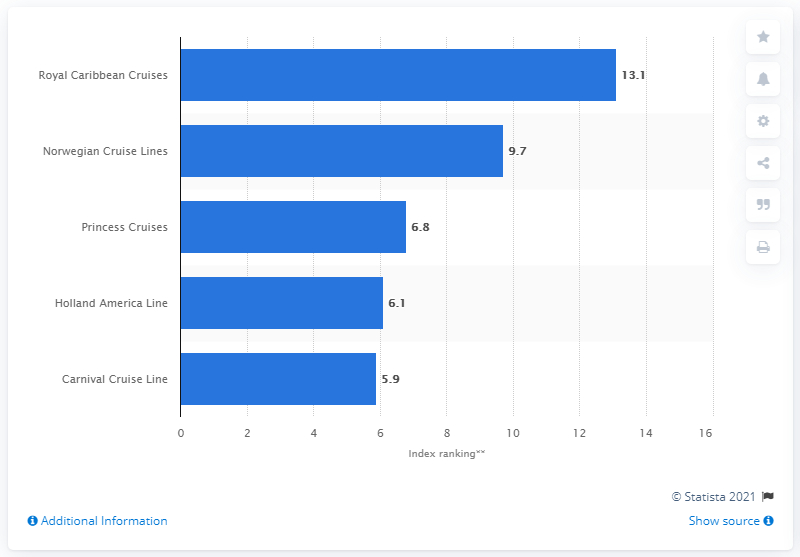Specify some key components in this picture. Norwegian Cruise Lines ranked 9.7 on YouGov's BrandIndex, making it one of the most highly regarded cruise lines according to consumer perception. Royal Caribbean Cruises had a score of 13.1 on YouGov's BrandIndex. 